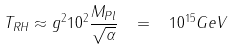Convert formula to latex. <formula><loc_0><loc_0><loc_500><loc_500>T _ { R H } \approx g ^ { 2 } 1 0 ^ { 2 } \frac { M _ { P l } } { \sqrt { \alpha } } \, \ = \, \ 1 0 ^ { 1 5 } G e V</formula> 